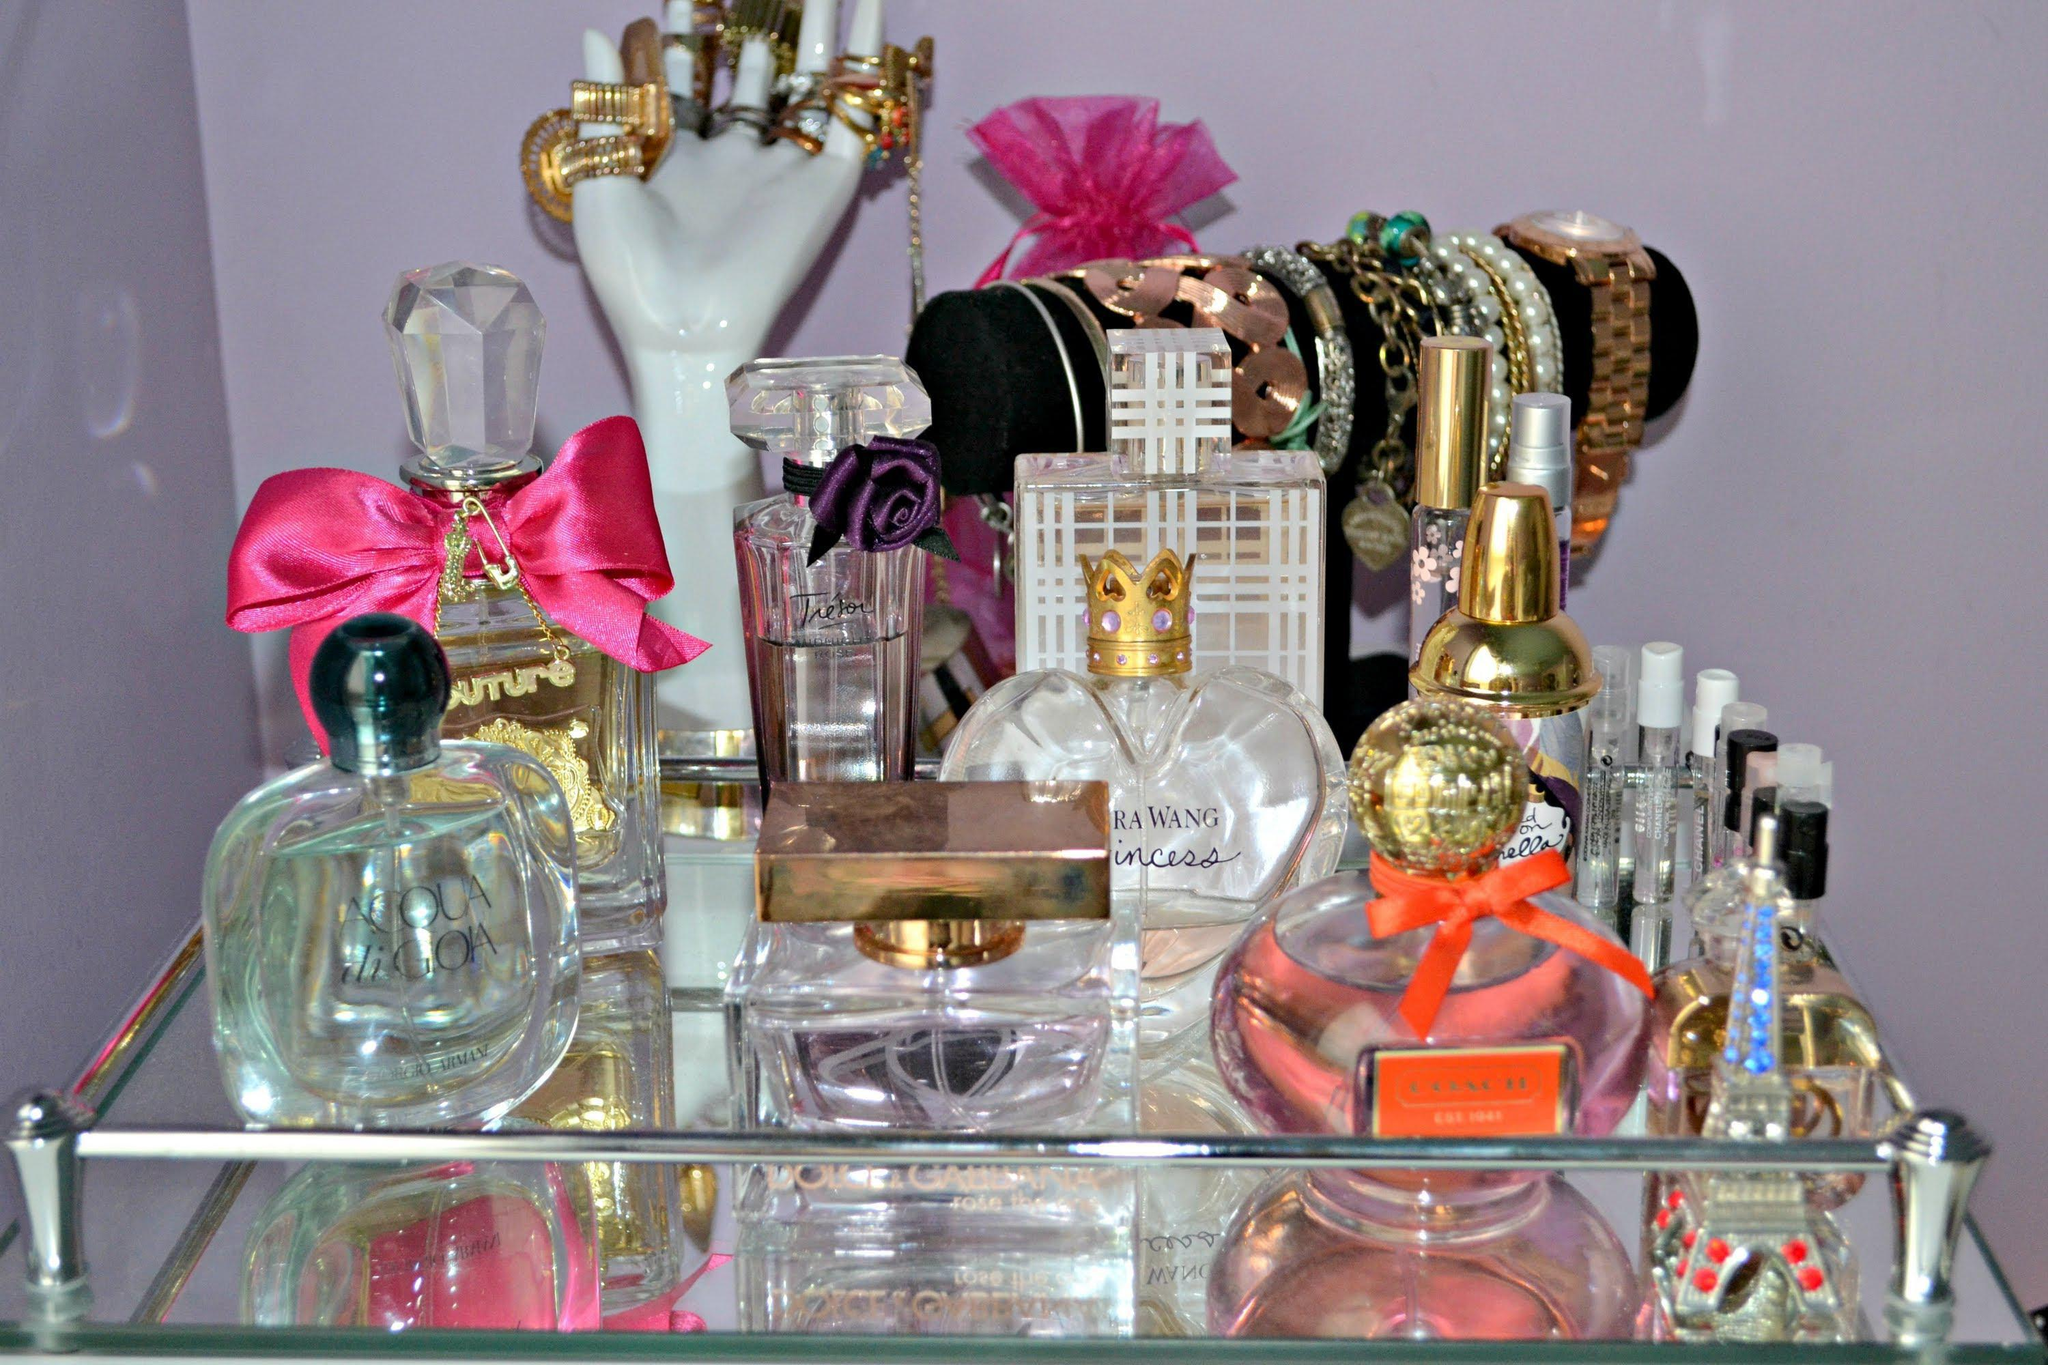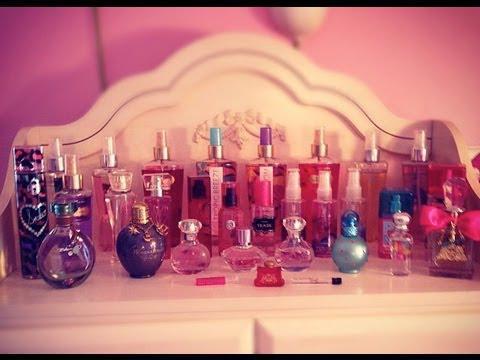The first image is the image on the left, the second image is the image on the right. Examine the images to the left and right. Is the description "The left image shows a collection of fragrance bottles on a tray, and the leftmost bottle in the front row has a round black cap." accurate? Answer yes or no. Yes. The first image is the image on the left, the second image is the image on the right. Given the left and right images, does the statement "In at least one image there are five different perfume bottles in a row." hold true? Answer yes or no. Yes. 